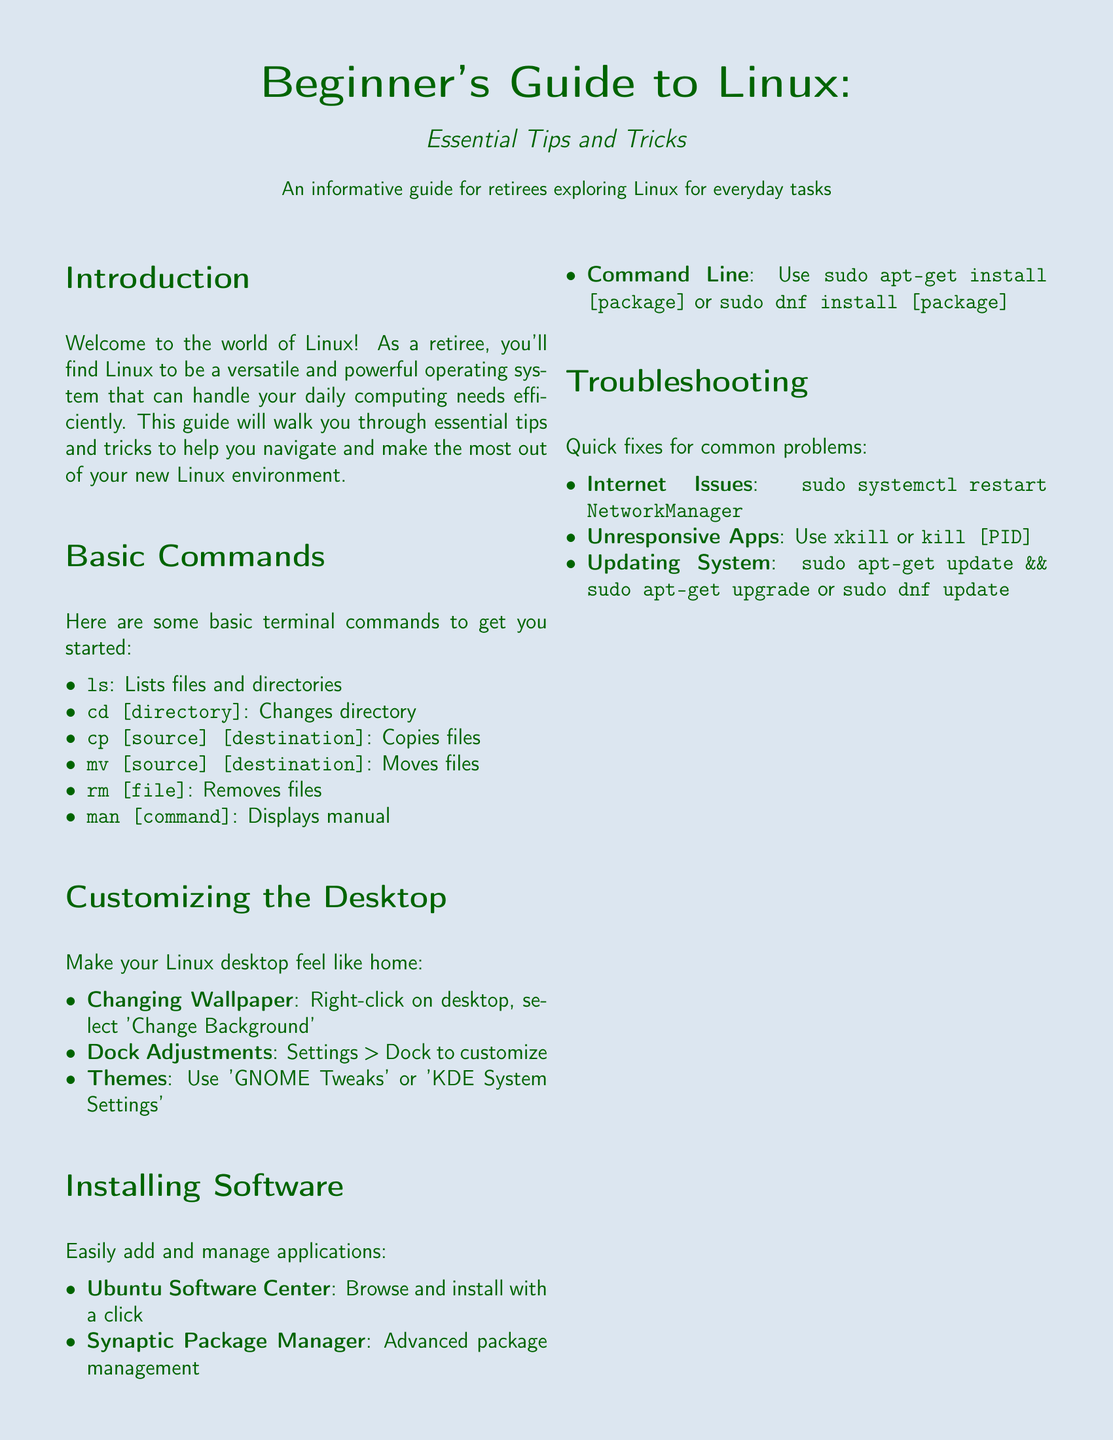what is the title of the guide? The title is found at the top of the document, clearly stated in large font.
Answer: Beginner's Guide to Linux who is the intended audience of the guide? The intended audience is specified in the introduction of the document.
Answer: retirees what command lists files and directories? The specific command is listed under the Basic Commands section.
Answer: ls what software center is mentioned for installation? This software center is referenced in the Installing Software section.
Answer: Ubuntu Software Center what command is used to update the system? This command is detailed in the Troubleshooting section.
Answer: sudo apt-get update && sudo apt-get upgrade how can you change the desktop wallpaper? The method for changing the wallpaper is described in the Customizing the Desktop section.
Answer: Right-click on desktop, select 'Change Background' what tool can be used for advanced package management? This tool is listed in the Installing Software section.
Answer: Synaptic Package Manager what command is suggested for restarting the network manager? The recommended command is outlined in the Troubleshooting section.
Answer: sudo systemctl restart NetworkManager what is the page color of the document? The page color is defined at the beginning of the document.
Answer: softblue 